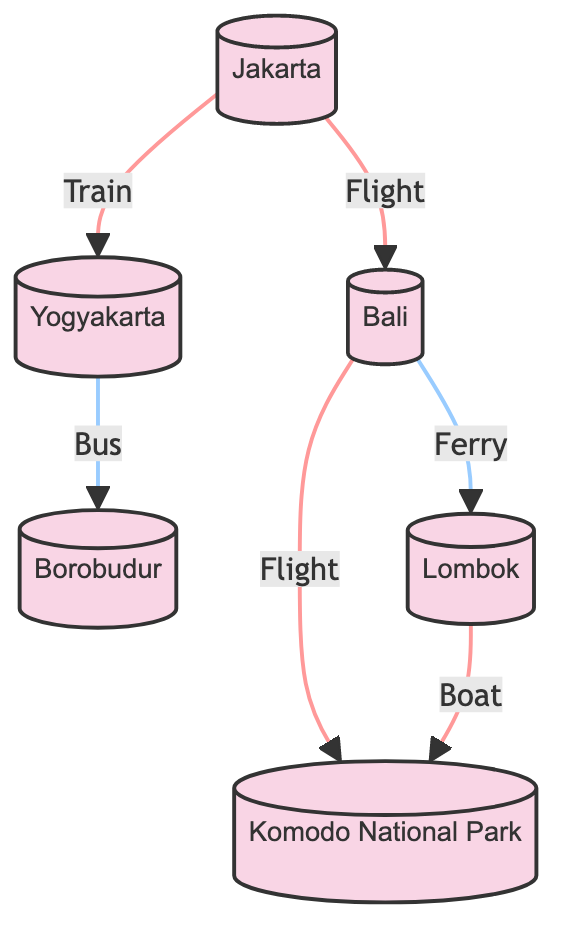What is the total number of destinations represented in the graph? The graph shows a total of six nodes, which represent destinations: Jakarta, Bali, Yogyakarta, Borobudur, Lombok, and Komodo National Park.
Answer: 6 Which destination has direct connections to the most other destinations? Bali connects to three other destinations: Jakarta, Lombok, and Komodo National Park, making it the destination with the most direct connections.
Answer: Bali How many travel routes lead directly from Jakarta? There are two routes originating from Jakarta, which connect to Bali and Yogyakarta.
Answer: 2 What type of transportation connects Yogyakarta and Borobudur? The graph indicates that a bus is the mode of transportation connecting Yogyakarta to Borobudur.
Answer: Bus Which two destinations are connected by a ferry? The ferry connects Bali and Lombok, as indicated by the directed edge labeled "Ferry" between these two nodes.
Answer: Bali and Lombok If a traveler goes from Bali to Komodo National Park, which route can they take? A traveler can take a direct flight from Bali to Komodo National Park, as represented in the directed edge connecting these two nodes.
Answer: Flight What is the relationship between Lombok and Komodo National Park? Lombok is connected to Komodo National Park by a boat, as shown by the directed edge between them.
Answer: Boat Which destination acts as a hub for routes leading to both Bali and Yogyakarta? Jakarta serves as the hub, with direct routes leading from Jakarta to both Bali and Yogyakarta.
Answer: Jakarta How many types of transportation are shown in the graph? There are three different types of transportation indicated in the graph: flight, train, bus, ferry, and boat, totaling five types of transportation.
Answer: 5 